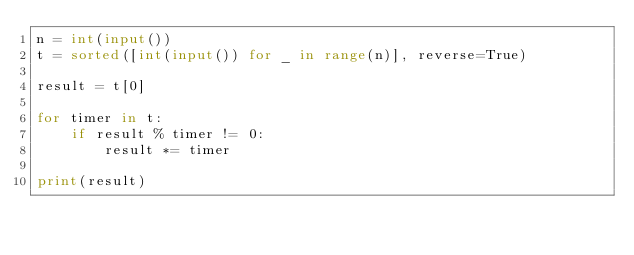<code> <loc_0><loc_0><loc_500><loc_500><_Python_>n = int(input())
t = sorted([int(input()) for _ in range(n)], reverse=True)

result = t[0]

for timer in t:
    if result % timer != 0:
        result *= timer
        
print(result)
</code> 